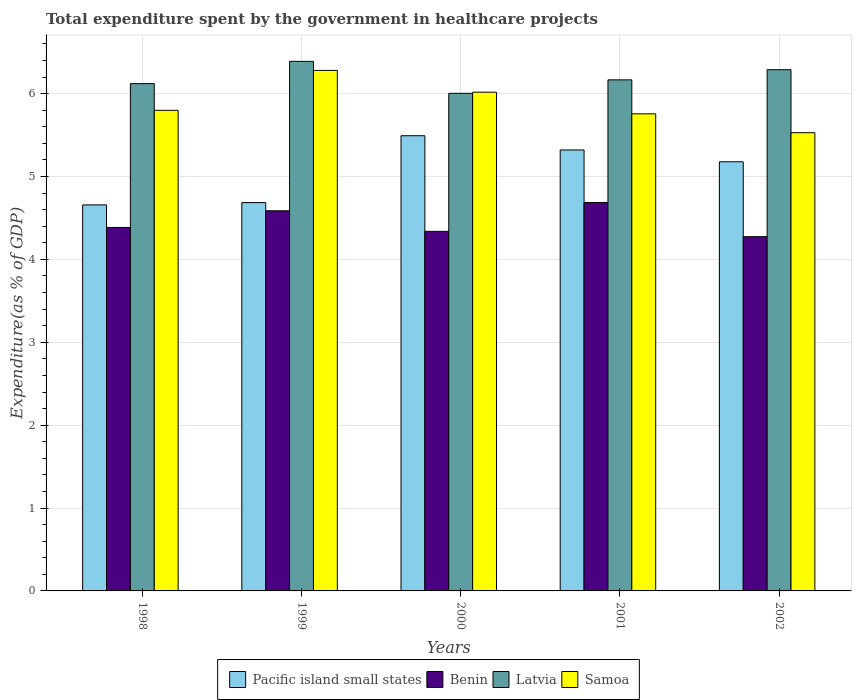Are the number of bars per tick equal to the number of legend labels?
Provide a succinct answer. Yes. Are the number of bars on each tick of the X-axis equal?
Keep it short and to the point. Yes. What is the total expenditure spent by the government in healthcare projects in Pacific island small states in 1999?
Your answer should be very brief. 4.69. Across all years, what is the maximum total expenditure spent by the government in healthcare projects in Latvia?
Ensure brevity in your answer.  6.39. Across all years, what is the minimum total expenditure spent by the government in healthcare projects in Benin?
Provide a succinct answer. 4.27. In which year was the total expenditure spent by the government in healthcare projects in Latvia maximum?
Your answer should be compact. 1999. In which year was the total expenditure spent by the government in healthcare projects in Pacific island small states minimum?
Ensure brevity in your answer.  1998. What is the total total expenditure spent by the government in healthcare projects in Latvia in the graph?
Ensure brevity in your answer.  30.97. What is the difference between the total expenditure spent by the government in healthcare projects in Samoa in 1999 and that in 2001?
Ensure brevity in your answer.  0.52. What is the difference between the total expenditure spent by the government in healthcare projects in Pacific island small states in 1998 and the total expenditure spent by the government in healthcare projects in Samoa in 2001?
Make the answer very short. -1.1. What is the average total expenditure spent by the government in healthcare projects in Samoa per year?
Offer a very short reply. 5.88. In the year 2001, what is the difference between the total expenditure spent by the government in healthcare projects in Benin and total expenditure spent by the government in healthcare projects in Samoa?
Make the answer very short. -1.07. What is the ratio of the total expenditure spent by the government in healthcare projects in Benin in 1999 to that in 2002?
Ensure brevity in your answer.  1.07. What is the difference between the highest and the second highest total expenditure spent by the government in healthcare projects in Samoa?
Make the answer very short. 0.26. What is the difference between the highest and the lowest total expenditure spent by the government in healthcare projects in Benin?
Your answer should be very brief. 0.41. Is the sum of the total expenditure spent by the government in healthcare projects in Benin in 1999 and 2000 greater than the maximum total expenditure spent by the government in healthcare projects in Samoa across all years?
Your response must be concise. Yes. Is it the case that in every year, the sum of the total expenditure spent by the government in healthcare projects in Samoa and total expenditure spent by the government in healthcare projects in Latvia is greater than the sum of total expenditure spent by the government in healthcare projects in Benin and total expenditure spent by the government in healthcare projects in Pacific island small states?
Your response must be concise. Yes. What does the 2nd bar from the left in 1999 represents?
Ensure brevity in your answer.  Benin. What does the 1st bar from the right in 1999 represents?
Make the answer very short. Samoa. Is it the case that in every year, the sum of the total expenditure spent by the government in healthcare projects in Benin and total expenditure spent by the government in healthcare projects in Pacific island small states is greater than the total expenditure spent by the government in healthcare projects in Samoa?
Provide a short and direct response. Yes. Are all the bars in the graph horizontal?
Your answer should be compact. No. How many years are there in the graph?
Offer a terse response. 5. Does the graph contain any zero values?
Your answer should be very brief. No. Does the graph contain grids?
Your answer should be very brief. Yes. Where does the legend appear in the graph?
Your answer should be very brief. Bottom center. How many legend labels are there?
Your response must be concise. 4. How are the legend labels stacked?
Provide a succinct answer. Horizontal. What is the title of the graph?
Ensure brevity in your answer.  Total expenditure spent by the government in healthcare projects. Does "East Asia (developing only)" appear as one of the legend labels in the graph?
Ensure brevity in your answer.  No. What is the label or title of the Y-axis?
Your response must be concise. Expenditure(as % of GDP). What is the Expenditure(as % of GDP) of Pacific island small states in 1998?
Provide a short and direct response. 4.66. What is the Expenditure(as % of GDP) of Benin in 1998?
Provide a short and direct response. 4.39. What is the Expenditure(as % of GDP) in Latvia in 1998?
Your answer should be compact. 6.12. What is the Expenditure(as % of GDP) in Samoa in 1998?
Give a very brief answer. 5.8. What is the Expenditure(as % of GDP) of Pacific island small states in 1999?
Your response must be concise. 4.69. What is the Expenditure(as % of GDP) in Benin in 1999?
Ensure brevity in your answer.  4.59. What is the Expenditure(as % of GDP) in Latvia in 1999?
Keep it short and to the point. 6.39. What is the Expenditure(as % of GDP) in Samoa in 1999?
Provide a succinct answer. 6.28. What is the Expenditure(as % of GDP) in Pacific island small states in 2000?
Offer a terse response. 5.49. What is the Expenditure(as % of GDP) of Benin in 2000?
Make the answer very short. 4.34. What is the Expenditure(as % of GDP) in Latvia in 2000?
Your answer should be compact. 6. What is the Expenditure(as % of GDP) of Samoa in 2000?
Ensure brevity in your answer.  6.02. What is the Expenditure(as % of GDP) of Pacific island small states in 2001?
Provide a succinct answer. 5.32. What is the Expenditure(as % of GDP) in Benin in 2001?
Offer a terse response. 4.69. What is the Expenditure(as % of GDP) in Latvia in 2001?
Provide a short and direct response. 6.17. What is the Expenditure(as % of GDP) in Samoa in 2001?
Keep it short and to the point. 5.76. What is the Expenditure(as % of GDP) in Pacific island small states in 2002?
Provide a succinct answer. 5.18. What is the Expenditure(as % of GDP) of Benin in 2002?
Provide a short and direct response. 4.27. What is the Expenditure(as % of GDP) in Latvia in 2002?
Offer a terse response. 6.29. What is the Expenditure(as % of GDP) of Samoa in 2002?
Offer a terse response. 5.53. Across all years, what is the maximum Expenditure(as % of GDP) in Pacific island small states?
Offer a very short reply. 5.49. Across all years, what is the maximum Expenditure(as % of GDP) of Benin?
Offer a very short reply. 4.69. Across all years, what is the maximum Expenditure(as % of GDP) of Latvia?
Provide a succinct answer. 6.39. Across all years, what is the maximum Expenditure(as % of GDP) in Samoa?
Your answer should be compact. 6.28. Across all years, what is the minimum Expenditure(as % of GDP) in Pacific island small states?
Provide a short and direct response. 4.66. Across all years, what is the minimum Expenditure(as % of GDP) in Benin?
Offer a very short reply. 4.27. Across all years, what is the minimum Expenditure(as % of GDP) of Latvia?
Your answer should be compact. 6. Across all years, what is the minimum Expenditure(as % of GDP) in Samoa?
Ensure brevity in your answer.  5.53. What is the total Expenditure(as % of GDP) of Pacific island small states in the graph?
Make the answer very short. 25.33. What is the total Expenditure(as % of GDP) in Benin in the graph?
Provide a short and direct response. 22.27. What is the total Expenditure(as % of GDP) in Latvia in the graph?
Your answer should be very brief. 30.97. What is the total Expenditure(as % of GDP) of Samoa in the graph?
Give a very brief answer. 29.38. What is the difference between the Expenditure(as % of GDP) of Pacific island small states in 1998 and that in 1999?
Your answer should be compact. -0.03. What is the difference between the Expenditure(as % of GDP) in Benin in 1998 and that in 1999?
Ensure brevity in your answer.  -0.2. What is the difference between the Expenditure(as % of GDP) of Latvia in 1998 and that in 1999?
Offer a very short reply. -0.27. What is the difference between the Expenditure(as % of GDP) in Samoa in 1998 and that in 1999?
Make the answer very short. -0.48. What is the difference between the Expenditure(as % of GDP) of Pacific island small states in 1998 and that in 2000?
Your response must be concise. -0.83. What is the difference between the Expenditure(as % of GDP) of Benin in 1998 and that in 2000?
Provide a short and direct response. 0.05. What is the difference between the Expenditure(as % of GDP) in Latvia in 1998 and that in 2000?
Your answer should be compact. 0.12. What is the difference between the Expenditure(as % of GDP) in Samoa in 1998 and that in 2000?
Offer a terse response. -0.22. What is the difference between the Expenditure(as % of GDP) in Pacific island small states in 1998 and that in 2001?
Your response must be concise. -0.66. What is the difference between the Expenditure(as % of GDP) in Benin in 1998 and that in 2001?
Give a very brief answer. -0.3. What is the difference between the Expenditure(as % of GDP) in Latvia in 1998 and that in 2001?
Your response must be concise. -0.05. What is the difference between the Expenditure(as % of GDP) of Samoa in 1998 and that in 2001?
Give a very brief answer. 0.04. What is the difference between the Expenditure(as % of GDP) in Pacific island small states in 1998 and that in 2002?
Your answer should be very brief. -0.52. What is the difference between the Expenditure(as % of GDP) of Benin in 1998 and that in 2002?
Provide a succinct answer. 0.11. What is the difference between the Expenditure(as % of GDP) of Latvia in 1998 and that in 2002?
Make the answer very short. -0.17. What is the difference between the Expenditure(as % of GDP) of Samoa in 1998 and that in 2002?
Give a very brief answer. 0.27. What is the difference between the Expenditure(as % of GDP) of Pacific island small states in 1999 and that in 2000?
Offer a terse response. -0.81. What is the difference between the Expenditure(as % of GDP) in Benin in 1999 and that in 2000?
Your answer should be compact. 0.25. What is the difference between the Expenditure(as % of GDP) in Latvia in 1999 and that in 2000?
Offer a terse response. 0.39. What is the difference between the Expenditure(as % of GDP) in Samoa in 1999 and that in 2000?
Make the answer very short. 0.26. What is the difference between the Expenditure(as % of GDP) of Pacific island small states in 1999 and that in 2001?
Your answer should be compact. -0.64. What is the difference between the Expenditure(as % of GDP) in Benin in 1999 and that in 2001?
Offer a terse response. -0.1. What is the difference between the Expenditure(as % of GDP) in Latvia in 1999 and that in 2001?
Your answer should be very brief. 0.22. What is the difference between the Expenditure(as % of GDP) in Samoa in 1999 and that in 2001?
Your answer should be very brief. 0.52. What is the difference between the Expenditure(as % of GDP) in Pacific island small states in 1999 and that in 2002?
Ensure brevity in your answer.  -0.49. What is the difference between the Expenditure(as % of GDP) of Benin in 1999 and that in 2002?
Your answer should be very brief. 0.31. What is the difference between the Expenditure(as % of GDP) in Latvia in 1999 and that in 2002?
Offer a very short reply. 0.1. What is the difference between the Expenditure(as % of GDP) of Samoa in 1999 and that in 2002?
Your answer should be compact. 0.75. What is the difference between the Expenditure(as % of GDP) in Pacific island small states in 2000 and that in 2001?
Make the answer very short. 0.17. What is the difference between the Expenditure(as % of GDP) of Benin in 2000 and that in 2001?
Ensure brevity in your answer.  -0.35. What is the difference between the Expenditure(as % of GDP) of Latvia in 2000 and that in 2001?
Provide a short and direct response. -0.16. What is the difference between the Expenditure(as % of GDP) in Samoa in 2000 and that in 2001?
Ensure brevity in your answer.  0.26. What is the difference between the Expenditure(as % of GDP) of Pacific island small states in 2000 and that in 2002?
Give a very brief answer. 0.31. What is the difference between the Expenditure(as % of GDP) in Benin in 2000 and that in 2002?
Make the answer very short. 0.06. What is the difference between the Expenditure(as % of GDP) of Latvia in 2000 and that in 2002?
Offer a terse response. -0.28. What is the difference between the Expenditure(as % of GDP) in Samoa in 2000 and that in 2002?
Provide a short and direct response. 0.49. What is the difference between the Expenditure(as % of GDP) of Pacific island small states in 2001 and that in 2002?
Your answer should be very brief. 0.14. What is the difference between the Expenditure(as % of GDP) in Benin in 2001 and that in 2002?
Your response must be concise. 0.41. What is the difference between the Expenditure(as % of GDP) of Latvia in 2001 and that in 2002?
Keep it short and to the point. -0.12. What is the difference between the Expenditure(as % of GDP) in Samoa in 2001 and that in 2002?
Give a very brief answer. 0.23. What is the difference between the Expenditure(as % of GDP) of Pacific island small states in 1998 and the Expenditure(as % of GDP) of Benin in 1999?
Provide a succinct answer. 0.07. What is the difference between the Expenditure(as % of GDP) in Pacific island small states in 1998 and the Expenditure(as % of GDP) in Latvia in 1999?
Ensure brevity in your answer.  -1.73. What is the difference between the Expenditure(as % of GDP) of Pacific island small states in 1998 and the Expenditure(as % of GDP) of Samoa in 1999?
Ensure brevity in your answer.  -1.62. What is the difference between the Expenditure(as % of GDP) of Benin in 1998 and the Expenditure(as % of GDP) of Latvia in 1999?
Provide a short and direct response. -2. What is the difference between the Expenditure(as % of GDP) of Benin in 1998 and the Expenditure(as % of GDP) of Samoa in 1999?
Give a very brief answer. -1.9. What is the difference between the Expenditure(as % of GDP) in Latvia in 1998 and the Expenditure(as % of GDP) in Samoa in 1999?
Your answer should be very brief. -0.16. What is the difference between the Expenditure(as % of GDP) of Pacific island small states in 1998 and the Expenditure(as % of GDP) of Benin in 2000?
Your response must be concise. 0.32. What is the difference between the Expenditure(as % of GDP) in Pacific island small states in 1998 and the Expenditure(as % of GDP) in Latvia in 2000?
Your response must be concise. -1.35. What is the difference between the Expenditure(as % of GDP) in Pacific island small states in 1998 and the Expenditure(as % of GDP) in Samoa in 2000?
Give a very brief answer. -1.36. What is the difference between the Expenditure(as % of GDP) of Benin in 1998 and the Expenditure(as % of GDP) of Latvia in 2000?
Give a very brief answer. -1.62. What is the difference between the Expenditure(as % of GDP) in Benin in 1998 and the Expenditure(as % of GDP) in Samoa in 2000?
Provide a short and direct response. -1.63. What is the difference between the Expenditure(as % of GDP) in Latvia in 1998 and the Expenditure(as % of GDP) in Samoa in 2000?
Your answer should be very brief. 0.1. What is the difference between the Expenditure(as % of GDP) in Pacific island small states in 1998 and the Expenditure(as % of GDP) in Benin in 2001?
Your answer should be very brief. -0.03. What is the difference between the Expenditure(as % of GDP) in Pacific island small states in 1998 and the Expenditure(as % of GDP) in Latvia in 2001?
Give a very brief answer. -1.51. What is the difference between the Expenditure(as % of GDP) in Pacific island small states in 1998 and the Expenditure(as % of GDP) in Samoa in 2001?
Offer a terse response. -1.1. What is the difference between the Expenditure(as % of GDP) of Benin in 1998 and the Expenditure(as % of GDP) of Latvia in 2001?
Your answer should be very brief. -1.78. What is the difference between the Expenditure(as % of GDP) in Benin in 1998 and the Expenditure(as % of GDP) in Samoa in 2001?
Ensure brevity in your answer.  -1.37. What is the difference between the Expenditure(as % of GDP) of Latvia in 1998 and the Expenditure(as % of GDP) of Samoa in 2001?
Provide a succinct answer. 0.36. What is the difference between the Expenditure(as % of GDP) of Pacific island small states in 1998 and the Expenditure(as % of GDP) of Benin in 2002?
Provide a succinct answer. 0.38. What is the difference between the Expenditure(as % of GDP) in Pacific island small states in 1998 and the Expenditure(as % of GDP) in Latvia in 2002?
Make the answer very short. -1.63. What is the difference between the Expenditure(as % of GDP) in Pacific island small states in 1998 and the Expenditure(as % of GDP) in Samoa in 2002?
Offer a terse response. -0.87. What is the difference between the Expenditure(as % of GDP) of Benin in 1998 and the Expenditure(as % of GDP) of Latvia in 2002?
Make the answer very short. -1.9. What is the difference between the Expenditure(as % of GDP) of Benin in 1998 and the Expenditure(as % of GDP) of Samoa in 2002?
Provide a short and direct response. -1.14. What is the difference between the Expenditure(as % of GDP) in Latvia in 1998 and the Expenditure(as % of GDP) in Samoa in 2002?
Make the answer very short. 0.59. What is the difference between the Expenditure(as % of GDP) in Pacific island small states in 1999 and the Expenditure(as % of GDP) in Benin in 2000?
Your answer should be compact. 0.35. What is the difference between the Expenditure(as % of GDP) in Pacific island small states in 1999 and the Expenditure(as % of GDP) in Latvia in 2000?
Your answer should be compact. -1.32. What is the difference between the Expenditure(as % of GDP) in Pacific island small states in 1999 and the Expenditure(as % of GDP) in Samoa in 2000?
Provide a short and direct response. -1.33. What is the difference between the Expenditure(as % of GDP) of Benin in 1999 and the Expenditure(as % of GDP) of Latvia in 2000?
Offer a terse response. -1.42. What is the difference between the Expenditure(as % of GDP) in Benin in 1999 and the Expenditure(as % of GDP) in Samoa in 2000?
Provide a succinct answer. -1.43. What is the difference between the Expenditure(as % of GDP) in Latvia in 1999 and the Expenditure(as % of GDP) in Samoa in 2000?
Your answer should be very brief. 0.37. What is the difference between the Expenditure(as % of GDP) of Pacific island small states in 1999 and the Expenditure(as % of GDP) of Benin in 2001?
Offer a very short reply. -0. What is the difference between the Expenditure(as % of GDP) in Pacific island small states in 1999 and the Expenditure(as % of GDP) in Latvia in 2001?
Keep it short and to the point. -1.48. What is the difference between the Expenditure(as % of GDP) in Pacific island small states in 1999 and the Expenditure(as % of GDP) in Samoa in 2001?
Your answer should be very brief. -1.07. What is the difference between the Expenditure(as % of GDP) of Benin in 1999 and the Expenditure(as % of GDP) of Latvia in 2001?
Your answer should be compact. -1.58. What is the difference between the Expenditure(as % of GDP) of Benin in 1999 and the Expenditure(as % of GDP) of Samoa in 2001?
Provide a short and direct response. -1.17. What is the difference between the Expenditure(as % of GDP) of Latvia in 1999 and the Expenditure(as % of GDP) of Samoa in 2001?
Provide a short and direct response. 0.63. What is the difference between the Expenditure(as % of GDP) of Pacific island small states in 1999 and the Expenditure(as % of GDP) of Benin in 2002?
Your answer should be very brief. 0.41. What is the difference between the Expenditure(as % of GDP) of Pacific island small states in 1999 and the Expenditure(as % of GDP) of Latvia in 2002?
Offer a very short reply. -1.6. What is the difference between the Expenditure(as % of GDP) in Pacific island small states in 1999 and the Expenditure(as % of GDP) in Samoa in 2002?
Your answer should be very brief. -0.84. What is the difference between the Expenditure(as % of GDP) of Benin in 1999 and the Expenditure(as % of GDP) of Latvia in 2002?
Your response must be concise. -1.7. What is the difference between the Expenditure(as % of GDP) of Benin in 1999 and the Expenditure(as % of GDP) of Samoa in 2002?
Your answer should be very brief. -0.94. What is the difference between the Expenditure(as % of GDP) in Latvia in 1999 and the Expenditure(as % of GDP) in Samoa in 2002?
Offer a very short reply. 0.86. What is the difference between the Expenditure(as % of GDP) in Pacific island small states in 2000 and the Expenditure(as % of GDP) in Benin in 2001?
Your response must be concise. 0.81. What is the difference between the Expenditure(as % of GDP) of Pacific island small states in 2000 and the Expenditure(as % of GDP) of Latvia in 2001?
Offer a terse response. -0.67. What is the difference between the Expenditure(as % of GDP) of Pacific island small states in 2000 and the Expenditure(as % of GDP) of Samoa in 2001?
Your response must be concise. -0.26. What is the difference between the Expenditure(as % of GDP) in Benin in 2000 and the Expenditure(as % of GDP) in Latvia in 2001?
Your response must be concise. -1.83. What is the difference between the Expenditure(as % of GDP) in Benin in 2000 and the Expenditure(as % of GDP) in Samoa in 2001?
Your response must be concise. -1.42. What is the difference between the Expenditure(as % of GDP) of Latvia in 2000 and the Expenditure(as % of GDP) of Samoa in 2001?
Your response must be concise. 0.25. What is the difference between the Expenditure(as % of GDP) of Pacific island small states in 2000 and the Expenditure(as % of GDP) of Benin in 2002?
Keep it short and to the point. 1.22. What is the difference between the Expenditure(as % of GDP) of Pacific island small states in 2000 and the Expenditure(as % of GDP) of Latvia in 2002?
Ensure brevity in your answer.  -0.8. What is the difference between the Expenditure(as % of GDP) of Pacific island small states in 2000 and the Expenditure(as % of GDP) of Samoa in 2002?
Give a very brief answer. -0.04. What is the difference between the Expenditure(as % of GDP) of Benin in 2000 and the Expenditure(as % of GDP) of Latvia in 2002?
Provide a short and direct response. -1.95. What is the difference between the Expenditure(as % of GDP) of Benin in 2000 and the Expenditure(as % of GDP) of Samoa in 2002?
Make the answer very short. -1.19. What is the difference between the Expenditure(as % of GDP) in Latvia in 2000 and the Expenditure(as % of GDP) in Samoa in 2002?
Provide a short and direct response. 0.48. What is the difference between the Expenditure(as % of GDP) in Pacific island small states in 2001 and the Expenditure(as % of GDP) in Benin in 2002?
Your answer should be compact. 1.05. What is the difference between the Expenditure(as % of GDP) in Pacific island small states in 2001 and the Expenditure(as % of GDP) in Latvia in 2002?
Keep it short and to the point. -0.97. What is the difference between the Expenditure(as % of GDP) in Pacific island small states in 2001 and the Expenditure(as % of GDP) in Samoa in 2002?
Give a very brief answer. -0.21. What is the difference between the Expenditure(as % of GDP) of Benin in 2001 and the Expenditure(as % of GDP) of Latvia in 2002?
Give a very brief answer. -1.6. What is the difference between the Expenditure(as % of GDP) in Benin in 2001 and the Expenditure(as % of GDP) in Samoa in 2002?
Your answer should be compact. -0.84. What is the difference between the Expenditure(as % of GDP) in Latvia in 2001 and the Expenditure(as % of GDP) in Samoa in 2002?
Your answer should be compact. 0.64. What is the average Expenditure(as % of GDP) in Pacific island small states per year?
Your answer should be very brief. 5.07. What is the average Expenditure(as % of GDP) in Benin per year?
Your answer should be compact. 4.45. What is the average Expenditure(as % of GDP) in Latvia per year?
Make the answer very short. 6.19. What is the average Expenditure(as % of GDP) in Samoa per year?
Your answer should be compact. 5.88. In the year 1998, what is the difference between the Expenditure(as % of GDP) in Pacific island small states and Expenditure(as % of GDP) in Benin?
Offer a very short reply. 0.27. In the year 1998, what is the difference between the Expenditure(as % of GDP) in Pacific island small states and Expenditure(as % of GDP) in Latvia?
Keep it short and to the point. -1.46. In the year 1998, what is the difference between the Expenditure(as % of GDP) of Pacific island small states and Expenditure(as % of GDP) of Samoa?
Give a very brief answer. -1.14. In the year 1998, what is the difference between the Expenditure(as % of GDP) in Benin and Expenditure(as % of GDP) in Latvia?
Offer a terse response. -1.74. In the year 1998, what is the difference between the Expenditure(as % of GDP) in Benin and Expenditure(as % of GDP) in Samoa?
Your response must be concise. -1.41. In the year 1998, what is the difference between the Expenditure(as % of GDP) in Latvia and Expenditure(as % of GDP) in Samoa?
Make the answer very short. 0.32. In the year 1999, what is the difference between the Expenditure(as % of GDP) of Pacific island small states and Expenditure(as % of GDP) of Benin?
Make the answer very short. 0.1. In the year 1999, what is the difference between the Expenditure(as % of GDP) in Pacific island small states and Expenditure(as % of GDP) in Latvia?
Make the answer very short. -1.7. In the year 1999, what is the difference between the Expenditure(as % of GDP) of Pacific island small states and Expenditure(as % of GDP) of Samoa?
Keep it short and to the point. -1.6. In the year 1999, what is the difference between the Expenditure(as % of GDP) of Benin and Expenditure(as % of GDP) of Latvia?
Offer a very short reply. -1.8. In the year 1999, what is the difference between the Expenditure(as % of GDP) of Benin and Expenditure(as % of GDP) of Samoa?
Your response must be concise. -1.69. In the year 1999, what is the difference between the Expenditure(as % of GDP) of Latvia and Expenditure(as % of GDP) of Samoa?
Offer a very short reply. 0.11. In the year 2000, what is the difference between the Expenditure(as % of GDP) in Pacific island small states and Expenditure(as % of GDP) in Benin?
Provide a succinct answer. 1.15. In the year 2000, what is the difference between the Expenditure(as % of GDP) of Pacific island small states and Expenditure(as % of GDP) of Latvia?
Offer a very short reply. -0.51. In the year 2000, what is the difference between the Expenditure(as % of GDP) of Pacific island small states and Expenditure(as % of GDP) of Samoa?
Keep it short and to the point. -0.53. In the year 2000, what is the difference between the Expenditure(as % of GDP) of Benin and Expenditure(as % of GDP) of Latvia?
Your answer should be compact. -1.67. In the year 2000, what is the difference between the Expenditure(as % of GDP) in Benin and Expenditure(as % of GDP) in Samoa?
Provide a short and direct response. -1.68. In the year 2000, what is the difference between the Expenditure(as % of GDP) of Latvia and Expenditure(as % of GDP) of Samoa?
Give a very brief answer. -0.01. In the year 2001, what is the difference between the Expenditure(as % of GDP) of Pacific island small states and Expenditure(as % of GDP) of Benin?
Make the answer very short. 0.63. In the year 2001, what is the difference between the Expenditure(as % of GDP) of Pacific island small states and Expenditure(as % of GDP) of Latvia?
Offer a terse response. -0.85. In the year 2001, what is the difference between the Expenditure(as % of GDP) in Pacific island small states and Expenditure(as % of GDP) in Samoa?
Provide a succinct answer. -0.44. In the year 2001, what is the difference between the Expenditure(as % of GDP) in Benin and Expenditure(as % of GDP) in Latvia?
Offer a terse response. -1.48. In the year 2001, what is the difference between the Expenditure(as % of GDP) of Benin and Expenditure(as % of GDP) of Samoa?
Provide a short and direct response. -1.07. In the year 2001, what is the difference between the Expenditure(as % of GDP) of Latvia and Expenditure(as % of GDP) of Samoa?
Keep it short and to the point. 0.41. In the year 2002, what is the difference between the Expenditure(as % of GDP) of Pacific island small states and Expenditure(as % of GDP) of Benin?
Provide a succinct answer. 0.9. In the year 2002, what is the difference between the Expenditure(as % of GDP) of Pacific island small states and Expenditure(as % of GDP) of Latvia?
Keep it short and to the point. -1.11. In the year 2002, what is the difference between the Expenditure(as % of GDP) of Pacific island small states and Expenditure(as % of GDP) of Samoa?
Your response must be concise. -0.35. In the year 2002, what is the difference between the Expenditure(as % of GDP) of Benin and Expenditure(as % of GDP) of Latvia?
Your answer should be compact. -2.01. In the year 2002, what is the difference between the Expenditure(as % of GDP) in Benin and Expenditure(as % of GDP) in Samoa?
Make the answer very short. -1.25. In the year 2002, what is the difference between the Expenditure(as % of GDP) of Latvia and Expenditure(as % of GDP) of Samoa?
Make the answer very short. 0.76. What is the ratio of the Expenditure(as % of GDP) of Pacific island small states in 1998 to that in 1999?
Offer a terse response. 0.99. What is the ratio of the Expenditure(as % of GDP) of Benin in 1998 to that in 1999?
Ensure brevity in your answer.  0.96. What is the ratio of the Expenditure(as % of GDP) of Latvia in 1998 to that in 1999?
Your response must be concise. 0.96. What is the ratio of the Expenditure(as % of GDP) in Samoa in 1998 to that in 1999?
Your answer should be very brief. 0.92. What is the ratio of the Expenditure(as % of GDP) of Pacific island small states in 1998 to that in 2000?
Provide a short and direct response. 0.85. What is the ratio of the Expenditure(as % of GDP) in Benin in 1998 to that in 2000?
Provide a succinct answer. 1.01. What is the ratio of the Expenditure(as % of GDP) in Latvia in 1998 to that in 2000?
Provide a succinct answer. 1.02. What is the ratio of the Expenditure(as % of GDP) of Samoa in 1998 to that in 2000?
Your response must be concise. 0.96. What is the ratio of the Expenditure(as % of GDP) of Pacific island small states in 1998 to that in 2001?
Offer a terse response. 0.88. What is the ratio of the Expenditure(as % of GDP) in Benin in 1998 to that in 2001?
Provide a succinct answer. 0.94. What is the ratio of the Expenditure(as % of GDP) of Samoa in 1998 to that in 2001?
Your answer should be very brief. 1.01. What is the ratio of the Expenditure(as % of GDP) of Pacific island small states in 1998 to that in 2002?
Ensure brevity in your answer.  0.9. What is the ratio of the Expenditure(as % of GDP) of Latvia in 1998 to that in 2002?
Make the answer very short. 0.97. What is the ratio of the Expenditure(as % of GDP) in Samoa in 1998 to that in 2002?
Make the answer very short. 1.05. What is the ratio of the Expenditure(as % of GDP) in Pacific island small states in 1999 to that in 2000?
Keep it short and to the point. 0.85. What is the ratio of the Expenditure(as % of GDP) of Benin in 1999 to that in 2000?
Ensure brevity in your answer.  1.06. What is the ratio of the Expenditure(as % of GDP) of Latvia in 1999 to that in 2000?
Make the answer very short. 1.06. What is the ratio of the Expenditure(as % of GDP) in Samoa in 1999 to that in 2000?
Your answer should be compact. 1.04. What is the ratio of the Expenditure(as % of GDP) of Pacific island small states in 1999 to that in 2001?
Keep it short and to the point. 0.88. What is the ratio of the Expenditure(as % of GDP) of Benin in 1999 to that in 2001?
Your answer should be compact. 0.98. What is the ratio of the Expenditure(as % of GDP) of Latvia in 1999 to that in 2001?
Provide a short and direct response. 1.04. What is the ratio of the Expenditure(as % of GDP) of Samoa in 1999 to that in 2001?
Provide a succinct answer. 1.09. What is the ratio of the Expenditure(as % of GDP) of Pacific island small states in 1999 to that in 2002?
Your answer should be compact. 0.9. What is the ratio of the Expenditure(as % of GDP) in Benin in 1999 to that in 2002?
Your answer should be compact. 1.07. What is the ratio of the Expenditure(as % of GDP) in Samoa in 1999 to that in 2002?
Provide a succinct answer. 1.14. What is the ratio of the Expenditure(as % of GDP) of Pacific island small states in 2000 to that in 2001?
Your response must be concise. 1.03. What is the ratio of the Expenditure(as % of GDP) in Benin in 2000 to that in 2001?
Provide a succinct answer. 0.93. What is the ratio of the Expenditure(as % of GDP) of Latvia in 2000 to that in 2001?
Provide a succinct answer. 0.97. What is the ratio of the Expenditure(as % of GDP) of Samoa in 2000 to that in 2001?
Give a very brief answer. 1.05. What is the ratio of the Expenditure(as % of GDP) in Pacific island small states in 2000 to that in 2002?
Your answer should be compact. 1.06. What is the ratio of the Expenditure(as % of GDP) of Benin in 2000 to that in 2002?
Your answer should be compact. 1.01. What is the ratio of the Expenditure(as % of GDP) of Latvia in 2000 to that in 2002?
Ensure brevity in your answer.  0.95. What is the ratio of the Expenditure(as % of GDP) of Samoa in 2000 to that in 2002?
Ensure brevity in your answer.  1.09. What is the ratio of the Expenditure(as % of GDP) in Pacific island small states in 2001 to that in 2002?
Your answer should be compact. 1.03. What is the ratio of the Expenditure(as % of GDP) of Benin in 2001 to that in 2002?
Your response must be concise. 1.1. What is the ratio of the Expenditure(as % of GDP) of Latvia in 2001 to that in 2002?
Provide a succinct answer. 0.98. What is the ratio of the Expenditure(as % of GDP) in Samoa in 2001 to that in 2002?
Your answer should be compact. 1.04. What is the difference between the highest and the second highest Expenditure(as % of GDP) in Pacific island small states?
Provide a succinct answer. 0.17. What is the difference between the highest and the second highest Expenditure(as % of GDP) in Benin?
Provide a succinct answer. 0.1. What is the difference between the highest and the second highest Expenditure(as % of GDP) of Latvia?
Your answer should be compact. 0.1. What is the difference between the highest and the second highest Expenditure(as % of GDP) of Samoa?
Make the answer very short. 0.26. What is the difference between the highest and the lowest Expenditure(as % of GDP) of Pacific island small states?
Provide a succinct answer. 0.83. What is the difference between the highest and the lowest Expenditure(as % of GDP) in Benin?
Provide a succinct answer. 0.41. What is the difference between the highest and the lowest Expenditure(as % of GDP) in Latvia?
Your answer should be very brief. 0.39. What is the difference between the highest and the lowest Expenditure(as % of GDP) of Samoa?
Ensure brevity in your answer.  0.75. 